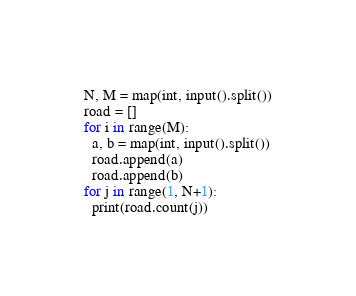<code> <loc_0><loc_0><loc_500><loc_500><_Python_>N, M = map(int, input().split())
road = []
for i in range(M):
  a, b = map(int, input().split())
  road.append(a)
  road.append(b)
for j in range(1, N+1):
  print(road.count(j))</code> 